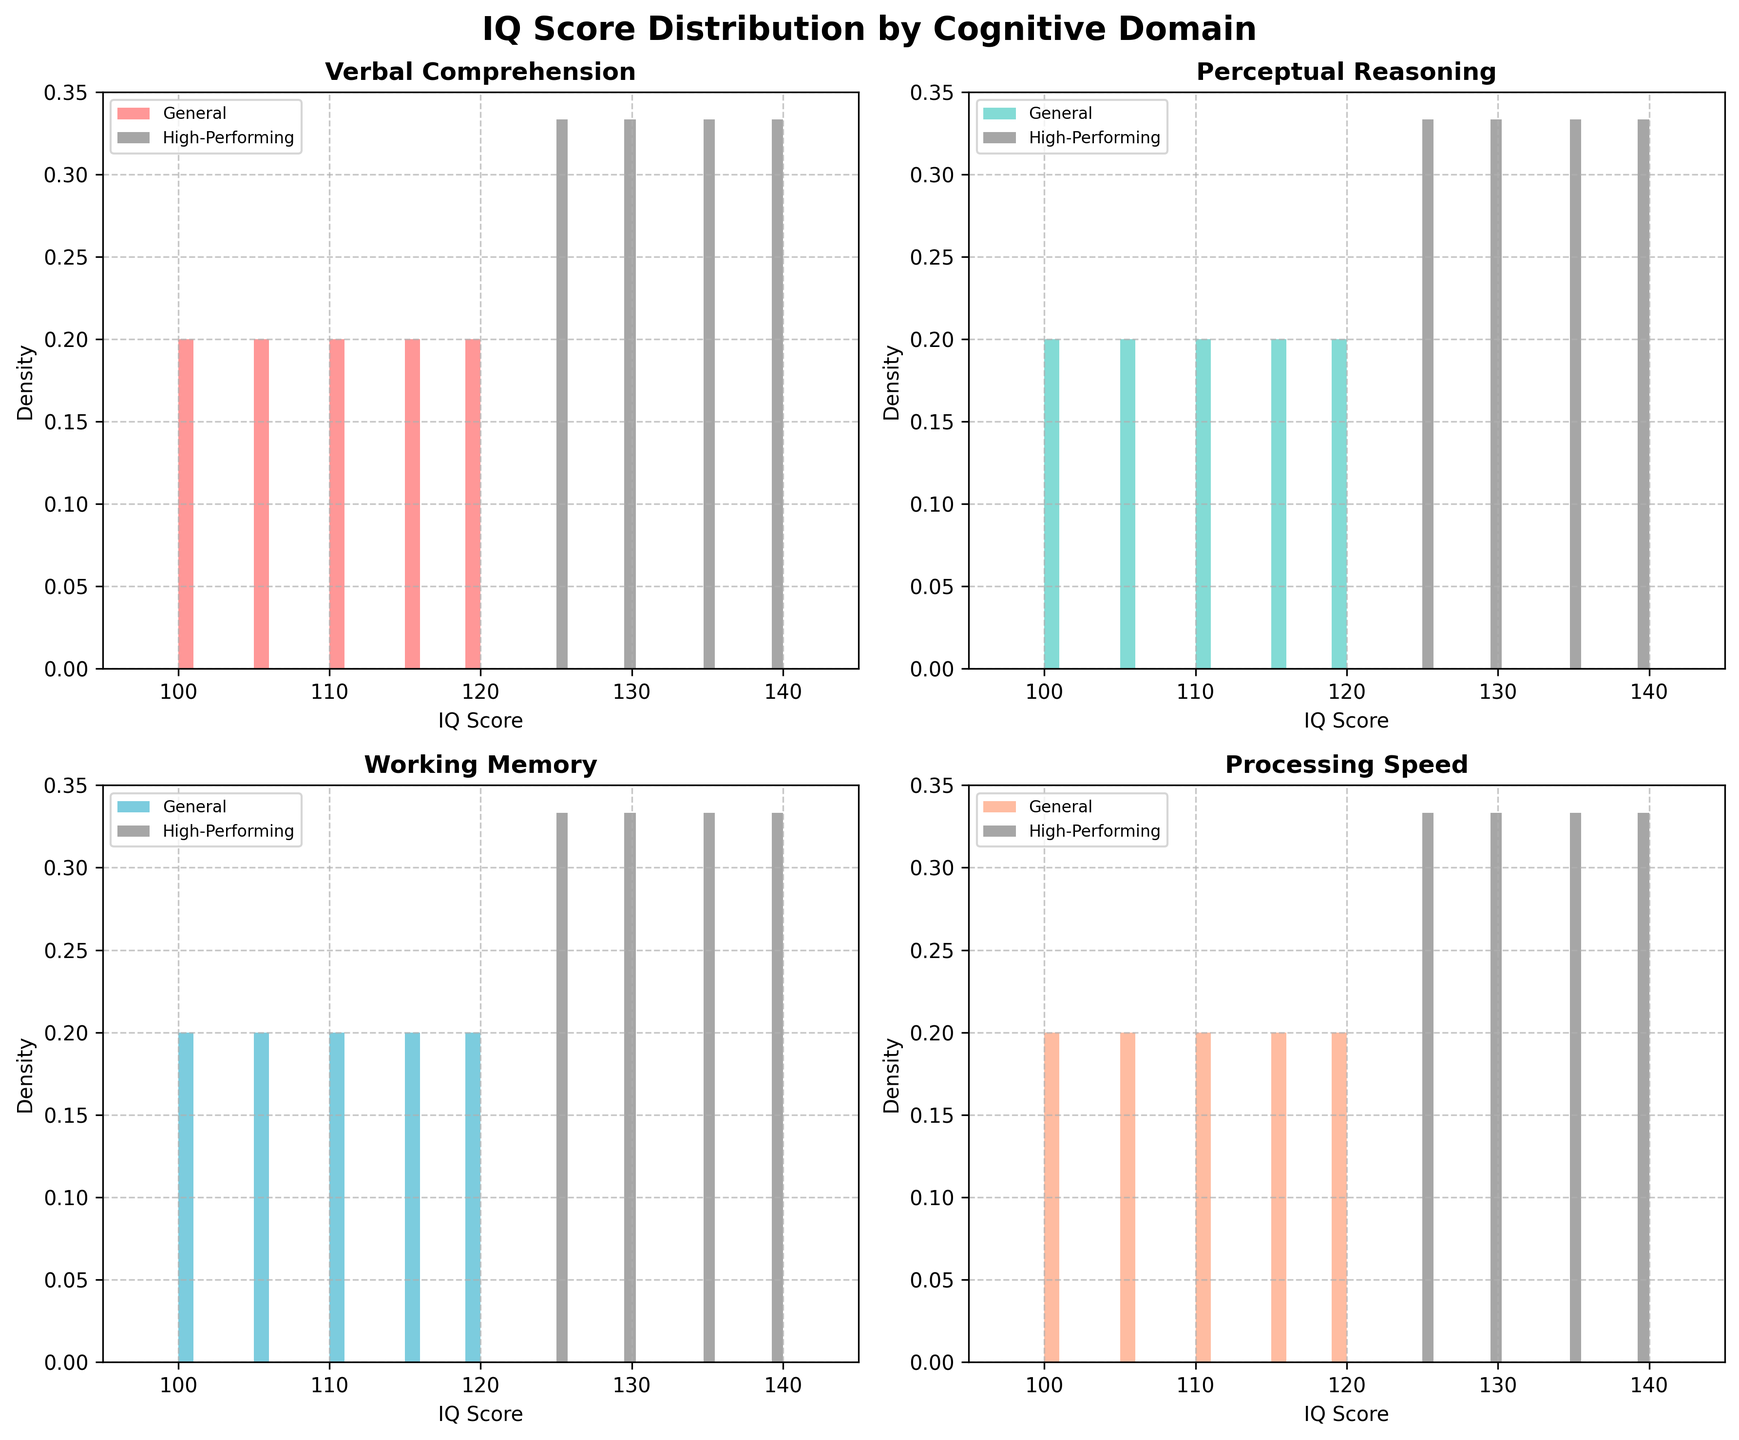What are the titles of the four subplots? The title for each subplot is given at the top of each histogram. They are "Verbal Comprehension", "Perceptual Reasoning", "Working Memory", and "Processing Speed."
Answer: Verbal Comprehension, Perceptual Reasoning, Working Memory, Processing Speed Which color is used for the "General" population histograms? The color used for the "General" population histograms varies by cognitive domain but follows a color scheme: '#FF6B6B', '#4ECDC4', '#45B7D1', and '#FFA07A'.
Answer: '#FF6B6B' (and similar specific colors) How does the peak density of "High-Performing" individuals compare to "General" individuals in the "Verbal Comprehension" domain? The density peak for "High-Performing" individuals is generally higher than for the "General" individuals in the "Verbal Comprehension" domain.
Answer: Higher Do "High-Performing" individuals exhibit higher IQ scores than the "General" population in the "Perceptual Reasoning" domain? Yes, the histogram shows that "High-Performing" individuals have higher IQ scores than the "General" population in the "Perceptual Reasoning" domain, with IQ scores starting from 125 and above.
Answer: Yes Which cognitive domain shows the largest spread in IQ scores for "High-Performing" individuals? By observing the histograms, the "Working Memory" domain shows the largest spread among "High-Performing" individuals, ranging from 125 to 140.
Answer: Working Memory What is the x-axis range common to all subplots? The x-axis range for all subplots is from 95 to 145, as set by the limits of each subplot.
Answer: 95 to 145 How is the density of IQ scores different between the "General" and "High-Performing" populations in the "Processing Speed" domain? The density for the "General" population is more centered around lower scores, while the "High-Performing" population density is centered around higher scores.
Answer: Centered around lower scores (General); centered around higher scores (High-Performing) In which cognitive domain is the difference in IQ score distributions between "General" and "High-Performing" populations the most pronounced? The "Verbal Comprehension" domain shows the most pronounced difference, as the "High-Performing" individuals have a peak in higher IQ scores than the "General" population.
Answer: Verbal Comprehension Which cognitive domain has the closest overlap in IQ score distributions between the "General" and "High-Performing" populations? The "Processing Speed" domain has the closest overlap, as both populations show significant densities around their respective peaks.
Answer: Processing Speed 